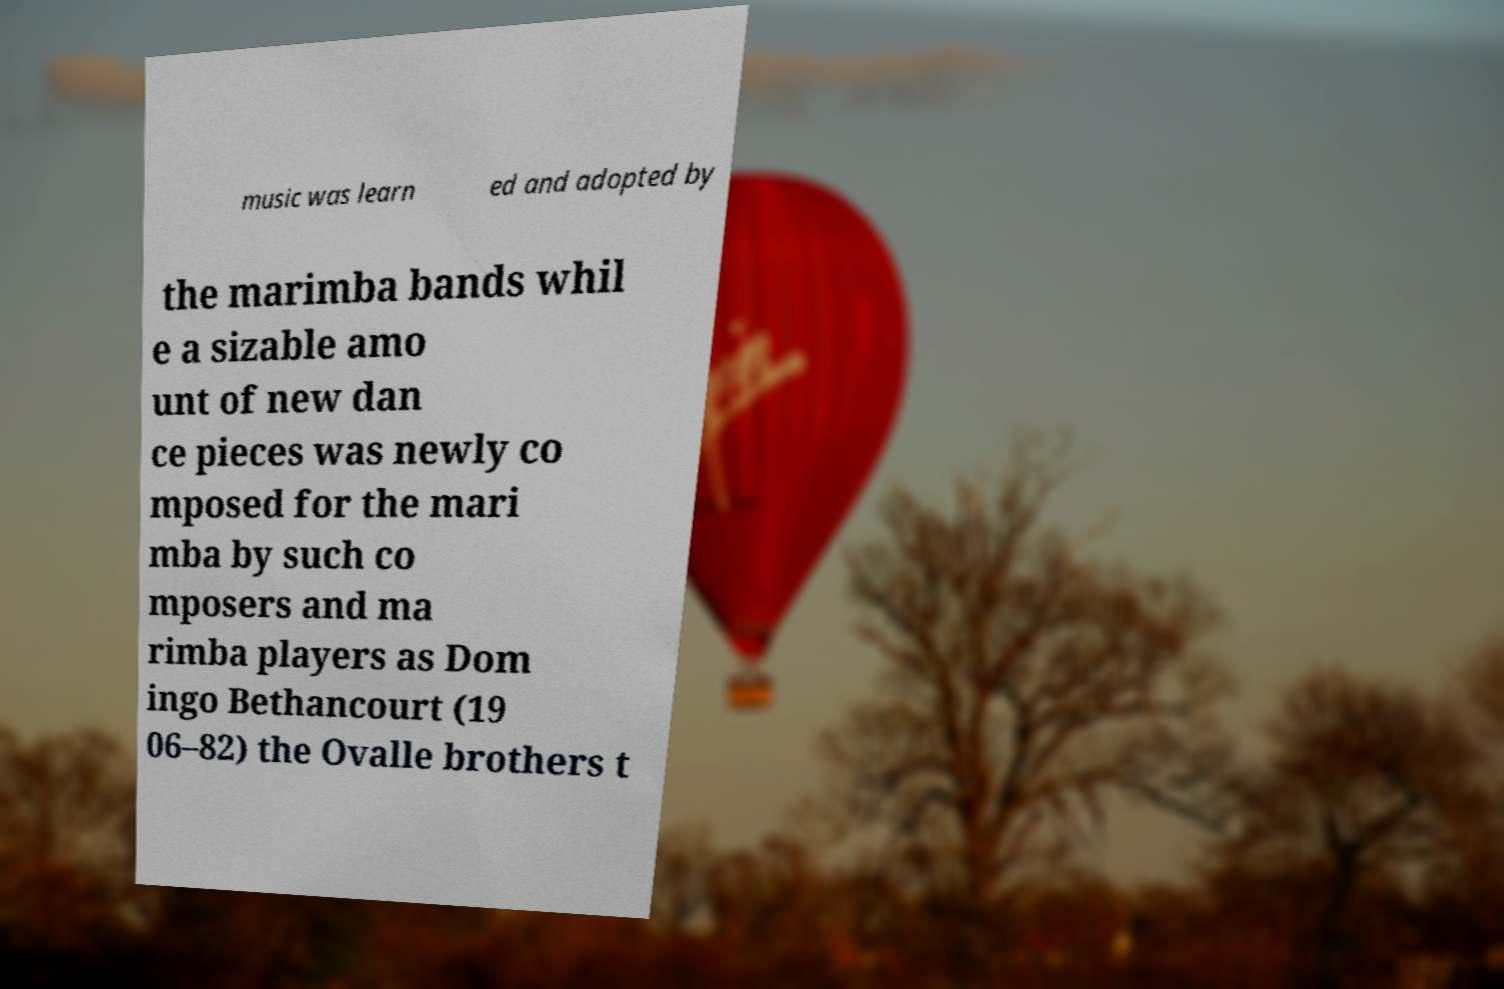I need the written content from this picture converted into text. Can you do that? music was learn ed and adopted by the marimba bands whil e a sizable amo unt of new dan ce pieces was newly co mposed for the mari mba by such co mposers and ma rimba players as Dom ingo Bethancourt (19 06–82) the Ovalle brothers t 